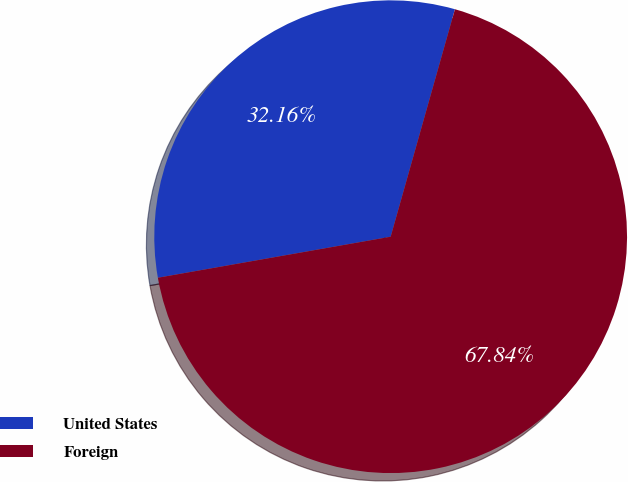<chart> <loc_0><loc_0><loc_500><loc_500><pie_chart><fcel>United States<fcel>Foreign<nl><fcel>32.16%<fcel>67.84%<nl></chart> 